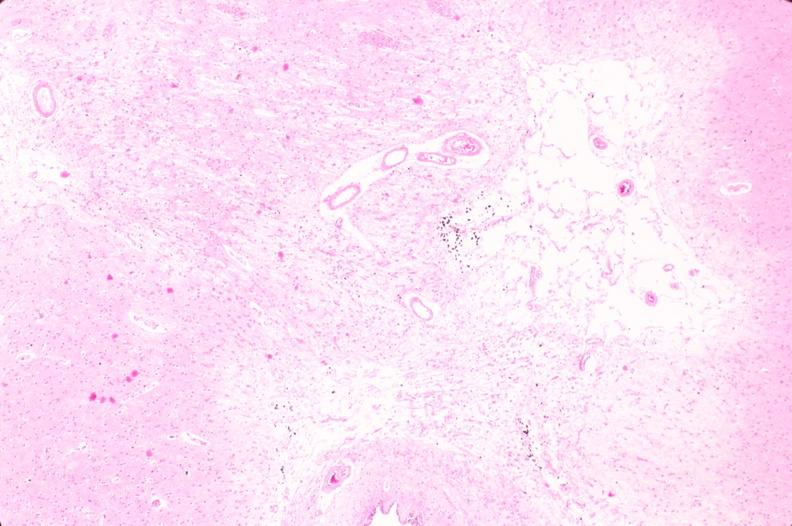s nervous present?
Answer the question using a single word or phrase. Yes 